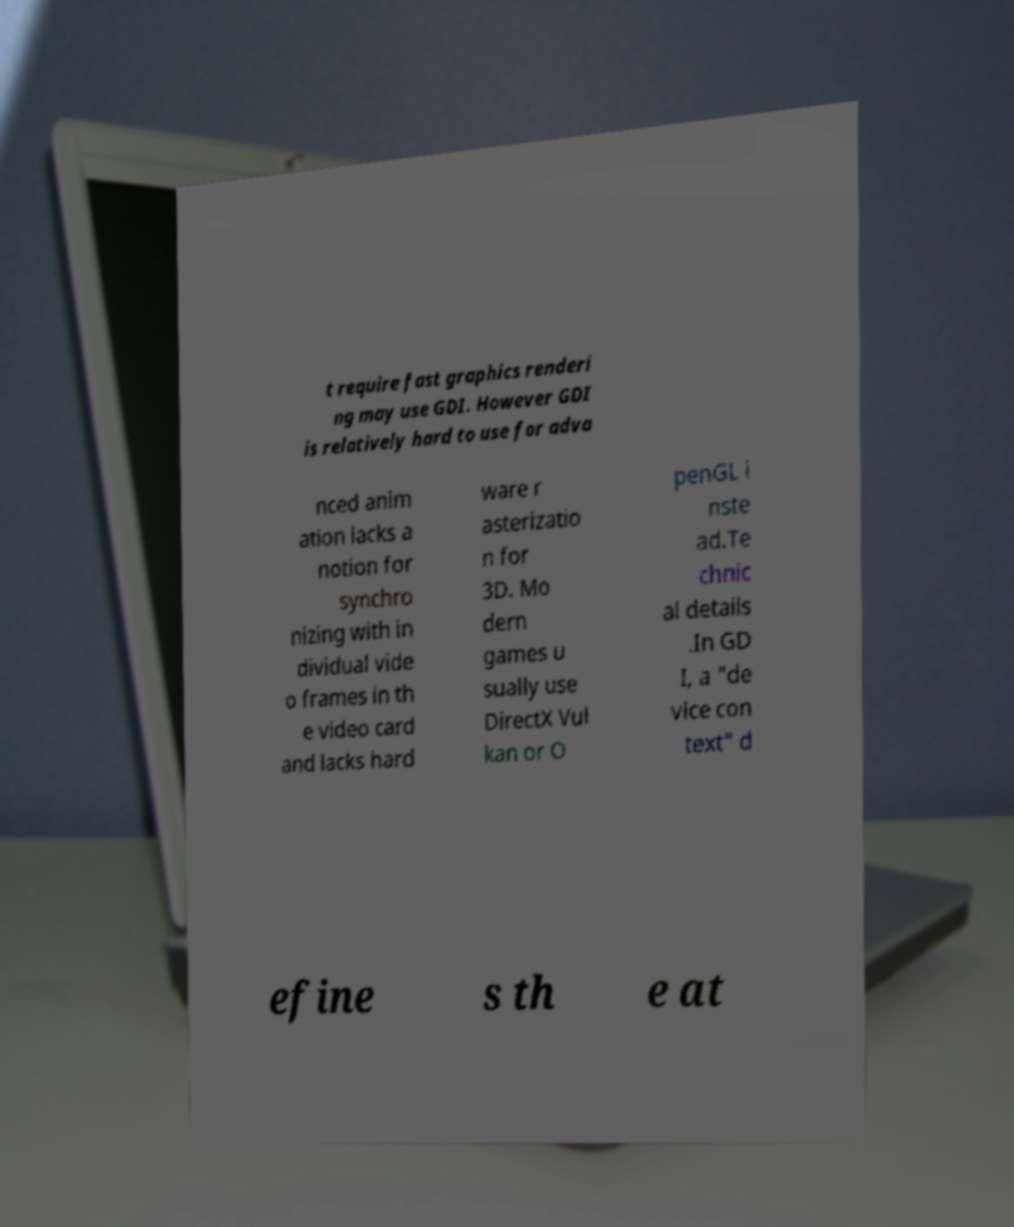For documentation purposes, I need the text within this image transcribed. Could you provide that? t require fast graphics renderi ng may use GDI. However GDI is relatively hard to use for adva nced anim ation lacks a notion for synchro nizing with in dividual vide o frames in th e video card and lacks hard ware r asterizatio n for 3D. Mo dern games u sually use DirectX Vul kan or O penGL i nste ad.Te chnic al details .In GD I, a "de vice con text" d efine s th e at 